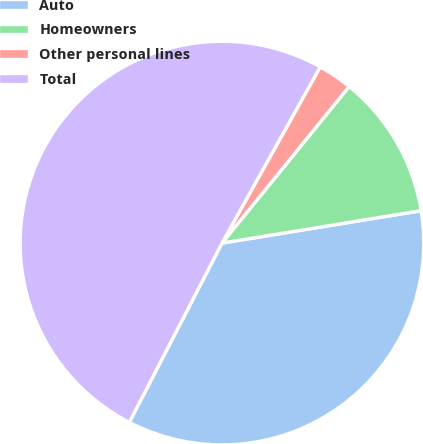<chart> <loc_0><loc_0><loc_500><loc_500><pie_chart><fcel>Auto<fcel>Homeowners<fcel>Other personal lines<fcel>Total<nl><fcel>35.16%<fcel>11.58%<fcel>2.76%<fcel>50.5%<nl></chart> 